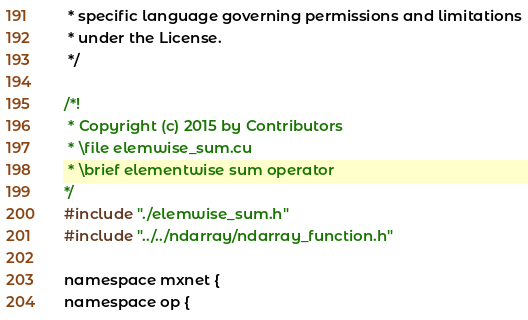<code> <loc_0><loc_0><loc_500><loc_500><_Cuda_> * specific language governing permissions and limitations
 * under the License.
 */

/*!
 * Copyright (c) 2015 by Contributors
 * \file elemwise_sum.cu
 * \brief elementwise sum operator
*/
#include "./elemwise_sum.h"
#include "../../ndarray/ndarray_function.h"

namespace mxnet {
namespace op {
</code> 